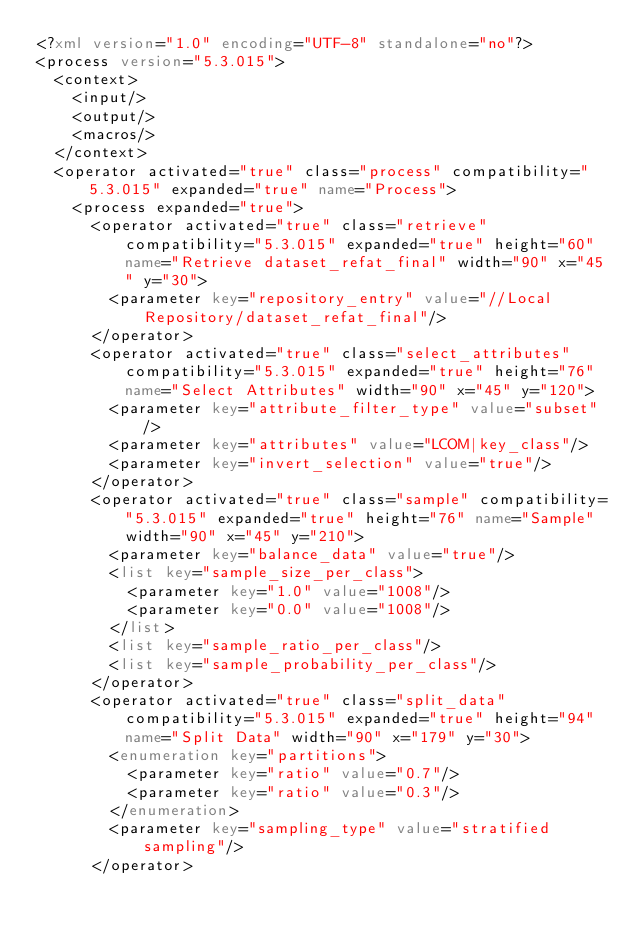<code> <loc_0><loc_0><loc_500><loc_500><_XML_><?xml version="1.0" encoding="UTF-8" standalone="no"?>
<process version="5.3.015">
  <context>
    <input/>
    <output/>
    <macros/>
  </context>
  <operator activated="true" class="process" compatibility="5.3.015" expanded="true" name="Process">
    <process expanded="true">
      <operator activated="true" class="retrieve" compatibility="5.3.015" expanded="true" height="60" name="Retrieve dataset_refat_final" width="90" x="45" y="30">
        <parameter key="repository_entry" value="//Local Repository/dataset_refat_final"/>
      </operator>
      <operator activated="true" class="select_attributes" compatibility="5.3.015" expanded="true" height="76" name="Select Attributes" width="90" x="45" y="120">
        <parameter key="attribute_filter_type" value="subset"/>
        <parameter key="attributes" value="LCOM|key_class"/>
        <parameter key="invert_selection" value="true"/>
      </operator>
      <operator activated="true" class="sample" compatibility="5.3.015" expanded="true" height="76" name="Sample" width="90" x="45" y="210">
        <parameter key="balance_data" value="true"/>
        <list key="sample_size_per_class">
          <parameter key="1.0" value="1008"/>
          <parameter key="0.0" value="1008"/>
        </list>
        <list key="sample_ratio_per_class"/>
        <list key="sample_probability_per_class"/>
      </operator>
      <operator activated="true" class="split_data" compatibility="5.3.015" expanded="true" height="94" name="Split Data" width="90" x="179" y="30">
        <enumeration key="partitions">
          <parameter key="ratio" value="0.7"/>
          <parameter key="ratio" value="0.3"/>
        </enumeration>
        <parameter key="sampling_type" value="stratified sampling"/>
      </operator></code> 